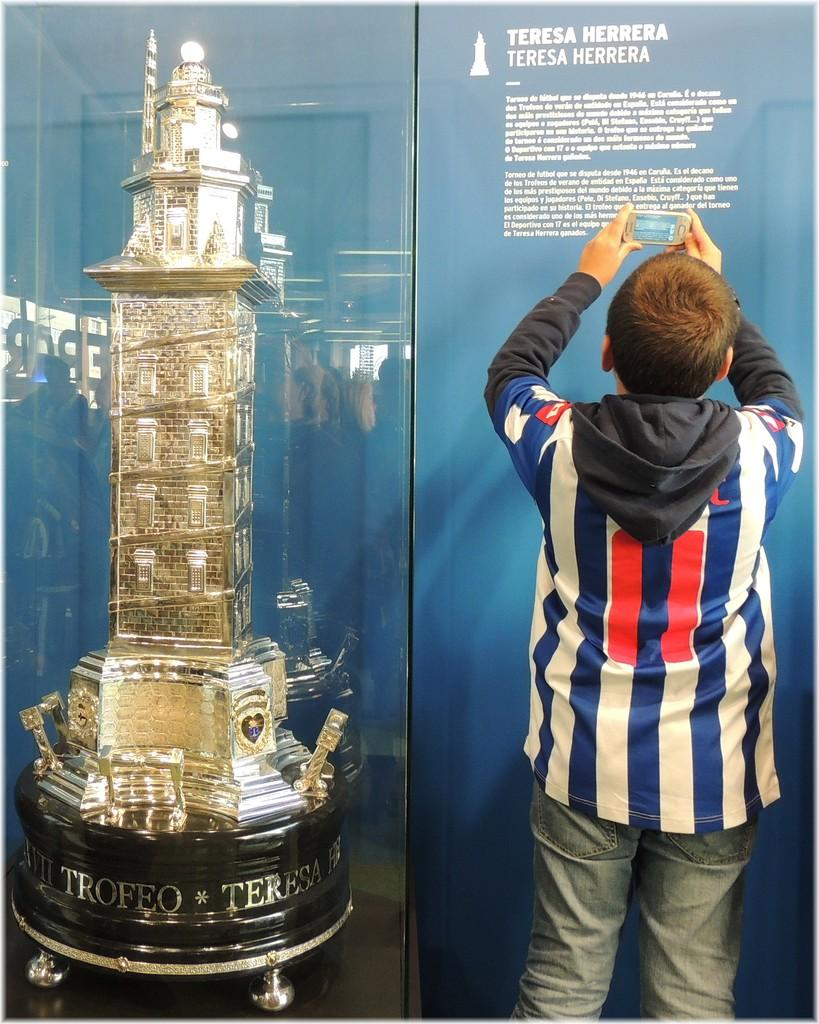Provide a one-sentence caption for the provided image. A boy is taking a picture of Theresa Herra memorial. 